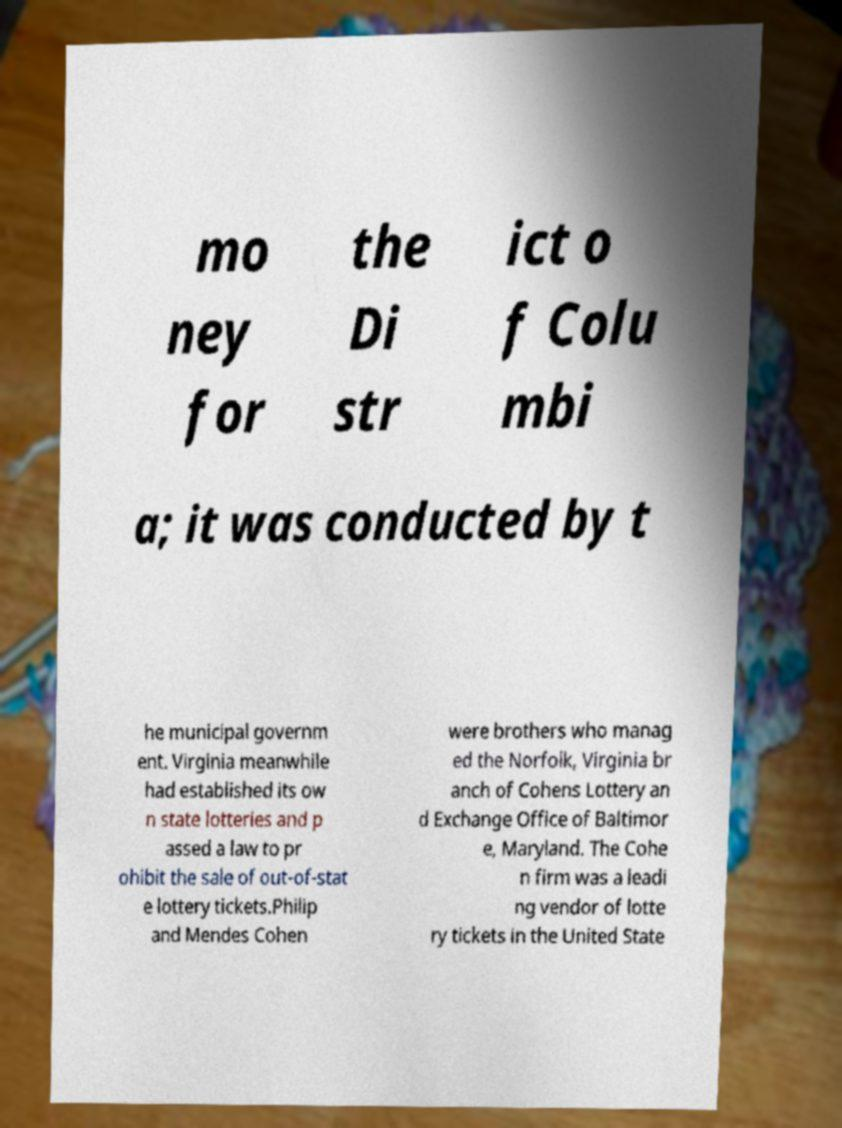Could you assist in decoding the text presented in this image and type it out clearly? mo ney for the Di str ict o f Colu mbi a; it was conducted by t he municipal governm ent. Virginia meanwhile had established its ow n state lotteries and p assed a law to pr ohibit the sale of out-of-stat e lottery tickets.Philip and Mendes Cohen were brothers who manag ed the Norfolk, Virginia br anch of Cohens Lottery an d Exchange Office of Baltimor e, Maryland. The Cohe n firm was a leadi ng vendor of lotte ry tickets in the United State 